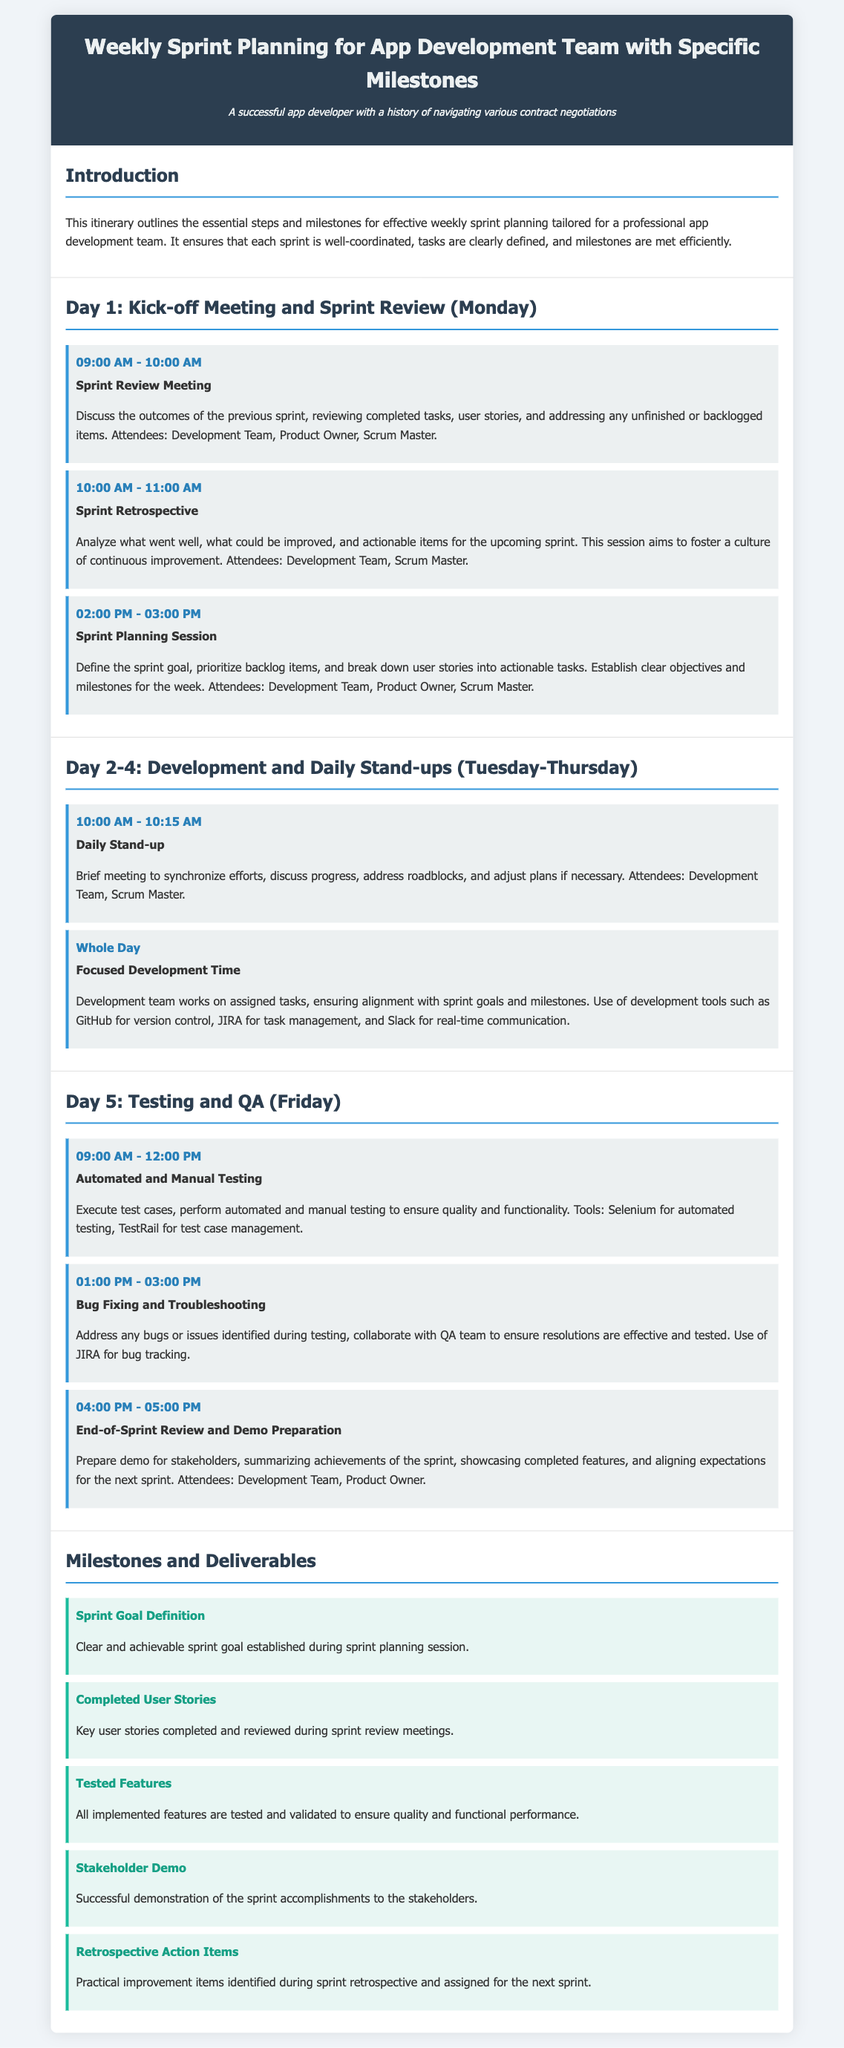What time does the Sprint Review Meeting start? The Sprint Review Meeting starts at 09:00 AM on Day 1 (Monday).
Answer: 09:00 AM What is the focus of the Daily Stand-up meetings? The Daily Stand-up meetings focus on synchronizing efforts, discussing progress, and addressing roadblocks.
Answer: Synchronizing efforts Who attends the Sprint Planning Session? The attendees of the Sprint Planning Session include the Development Team, Product Owner, and Scrum Master.
Answer: Development Team, Product Owner, Scrum Master What is the main activity scheduled for the whole day on Day 2-4? The main activity scheduled for the whole day on Day 2-4 is focused development time.
Answer: Focused Development Time What milestone is defined during the sprint planning session? The milestone defined during the sprint planning session is the Sprint Goal Definition.
Answer: Sprint Goal Definition How long is the Automated and Manual Testing session scheduled? The Automated and Manual Testing session is scheduled for three hours, from 09:00 AM to 12:00 PM.
Answer: Three hours What tool is mentioned for bug tracking? JIRA is mentioned as a tool for bug tracking in the document.
Answer: JIRA What is prepared during the End-of-Sprint Review? The topic prepared during the End-of-Sprint Review is a demo for stakeholders.
Answer: Demo for stakeholders What are the action items identified during the sprint retrospective referred to as? The action items identified during the sprint retrospective are referred to as Retrospective Action Items.
Answer: Retrospective Action Items 